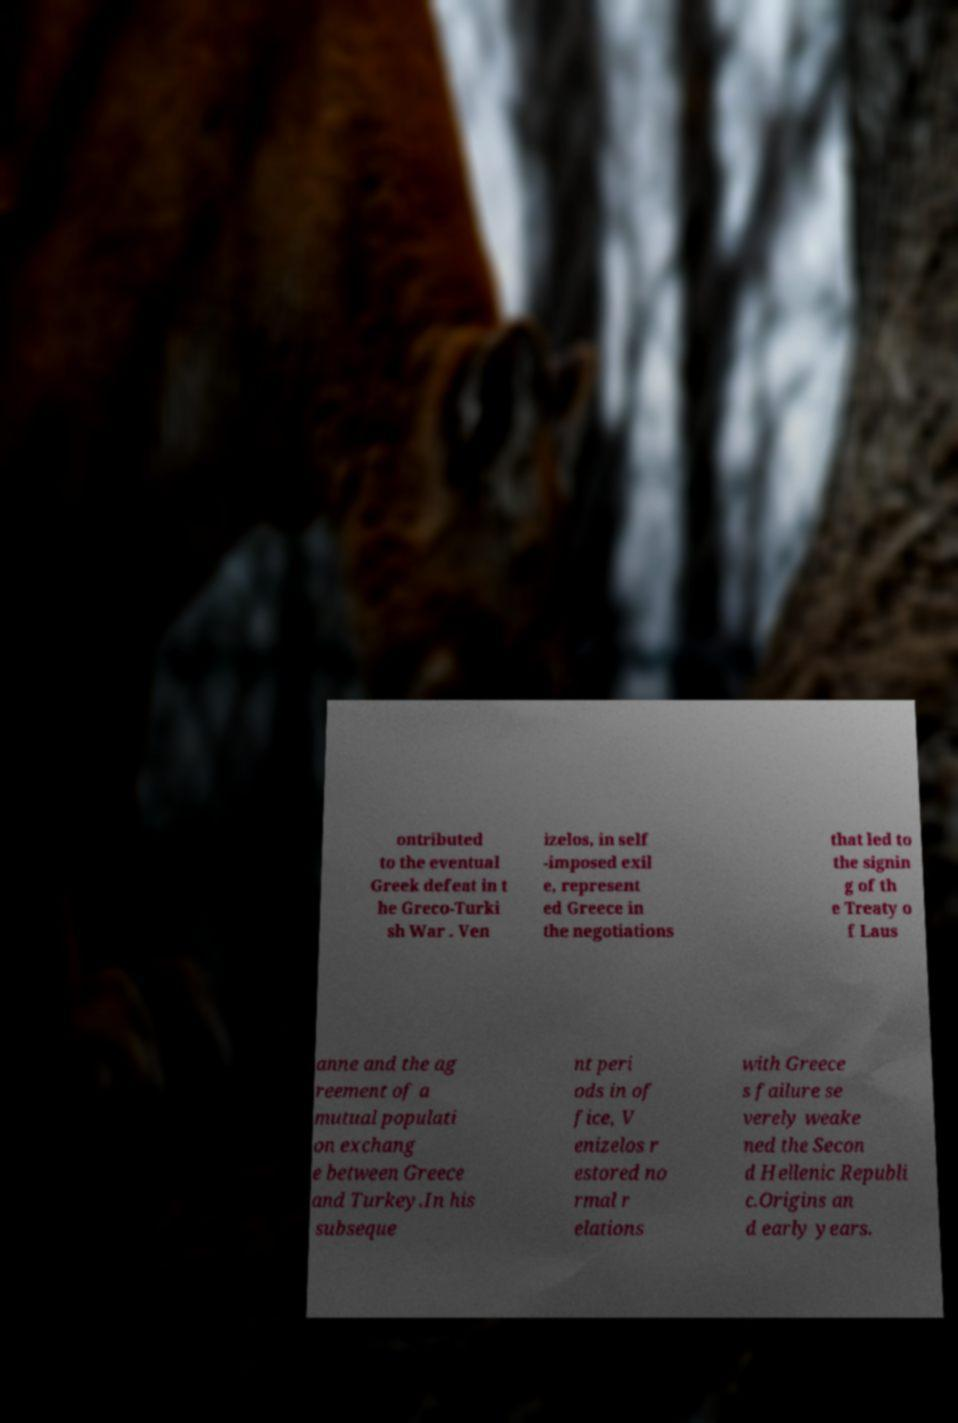Can you accurately transcribe the text from the provided image for me? ontributed to the eventual Greek defeat in t he Greco-Turki sh War . Ven izelos, in self -imposed exil e, represent ed Greece in the negotiations that led to the signin g of th e Treaty o f Laus anne and the ag reement of a mutual populati on exchang e between Greece and Turkey.In his subseque nt peri ods in of fice, V enizelos r estored no rmal r elations with Greece s failure se verely weake ned the Secon d Hellenic Republi c.Origins an d early years. 